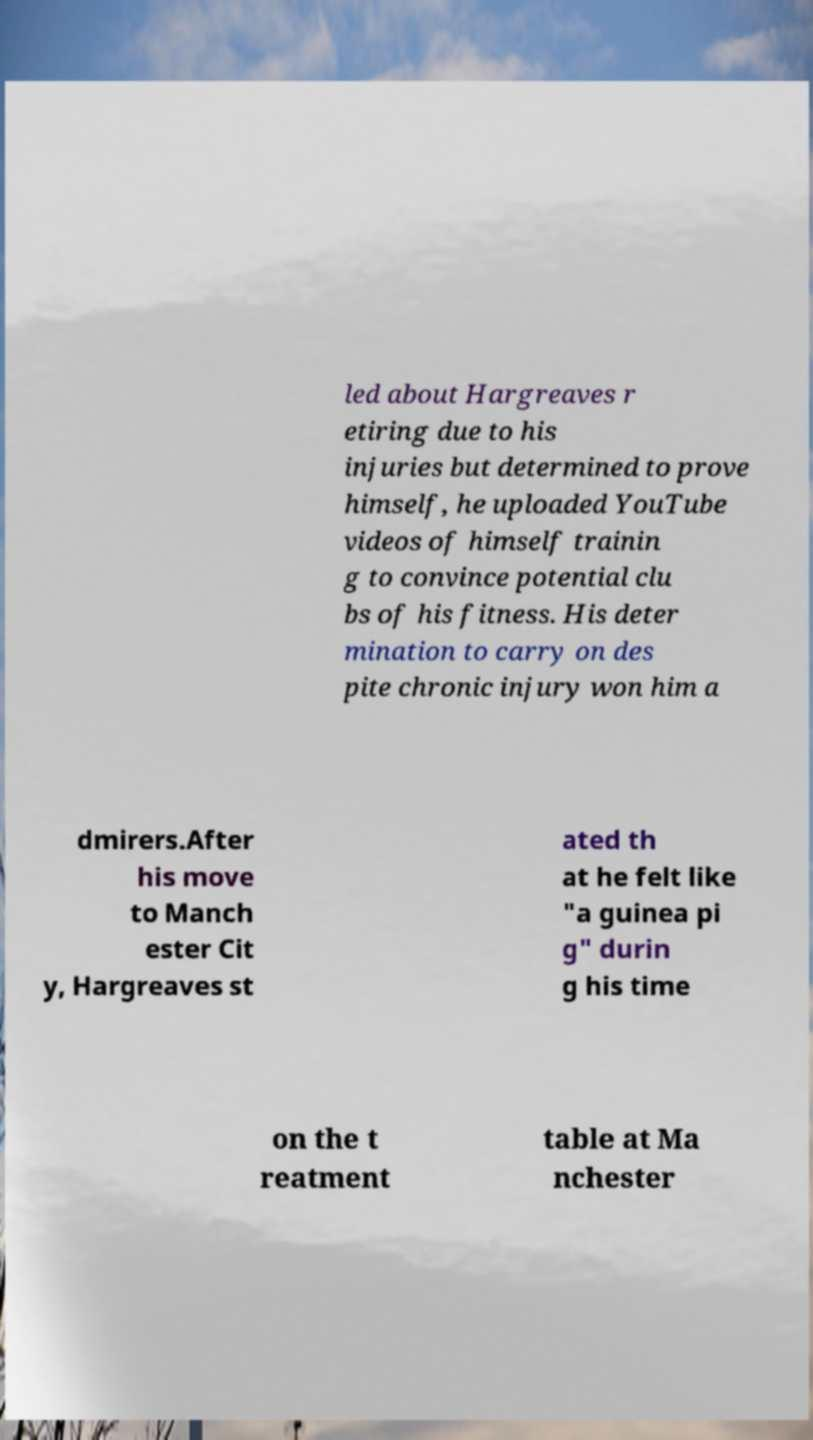Could you assist in decoding the text presented in this image and type it out clearly? led about Hargreaves r etiring due to his injuries but determined to prove himself, he uploaded YouTube videos of himself trainin g to convince potential clu bs of his fitness. His deter mination to carry on des pite chronic injury won him a dmirers.After his move to Manch ester Cit y, Hargreaves st ated th at he felt like "a guinea pi g" durin g his time on the t reatment table at Ma nchester 